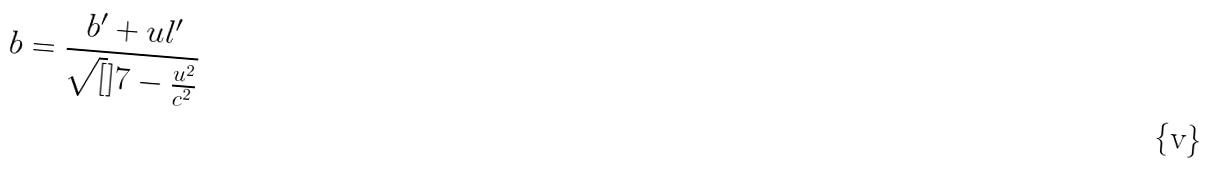Convert formula to latex. <formula><loc_0><loc_0><loc_500><loc_500>b = \frac { b ^ { \prime } + u l ^ { \prime } } { \sqrt { [ } ] { 7 - \frac { u ^ { 2 } } { c ^ { 2 } } } }</formula> 